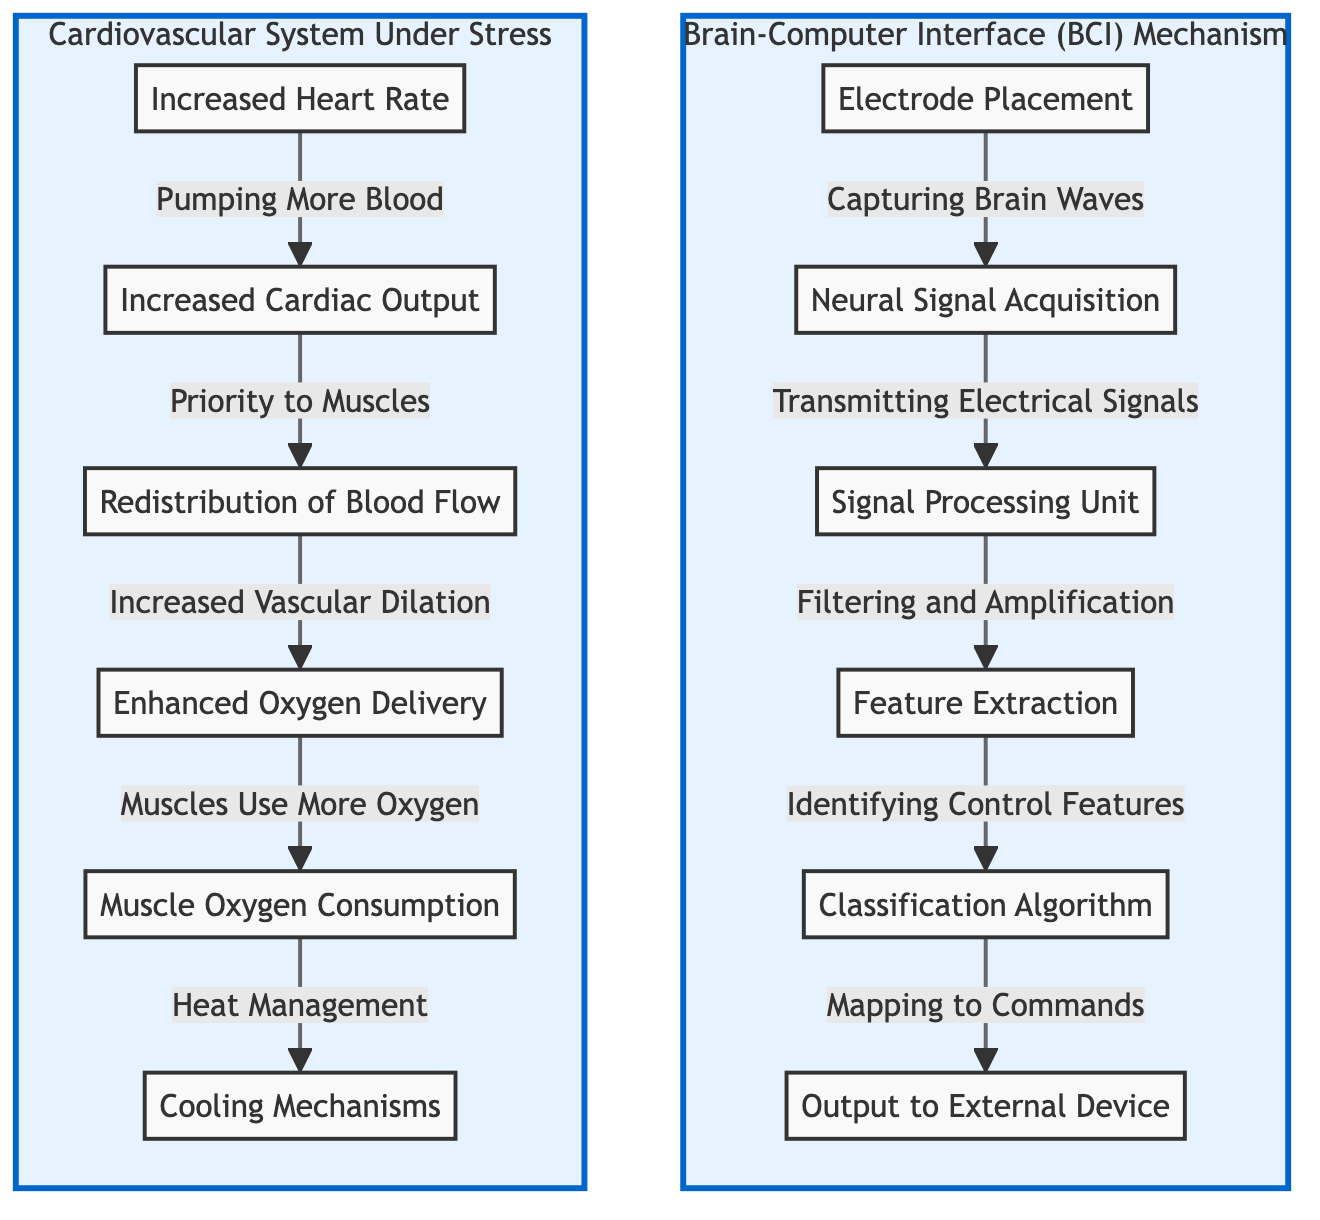What is the first step in the Brain-Computer Interface mechanism? The first step is "Electrode Placement," where electrodes are positioned to capture brain waves.
Answer: Electrode Placement How many main components are included in the Brain-Computer Interface section? There are six main components: Electrode Placement, Neural Signal Acquisition, Signal Processing Unit, Feature Extraction, Classification Algorithm, and Output to External Device.
Answer: Six What change occurs after "Increased Heart Rate"? After "Increased Heart Rate," the next change is "Increased Cardiac Output," indicating that the heart pumps more blood throughout the body.
Answer: Increased Cardiac Output Which factor directly affects "Muscle Oxygen Consumption"? The factor that directly affects "Muscle Oxygen Consumption" is "Enhanced Oxygen Delivery," indicating that muscles receive a greater supply of oxygen.
Answer: Enhanced Oxygen Delivery What happens to blood flow distribution during high-intensity gaming? Blood flow becomes "Redistributed," prioritizing supply to muscles over other organs during high-intensity gaming.
Answer: Redistributed What does the "Signal Processing Unit" do in the BCI mechanism? The "Signal Processing Unit" performs "Filtering and Amplification," enhancing the quality of the neural signals it processes from the electrodes.
Answer: Filtering and Amplification What physiological change is associated with heat management? "Cooling Mechanisms" are associated with heat management, which helps regulate body temperature during intense activity.
Answer: Cooling Mechanisms How does "Increased Cardiac Output" relate to the body's response to gaming? "Increased Cardiac Output" is the body's response to meet the heightened physical demands during gaming by delivering more blood and oxygen to active muscles.
Answer: Increased Cardiac Output 